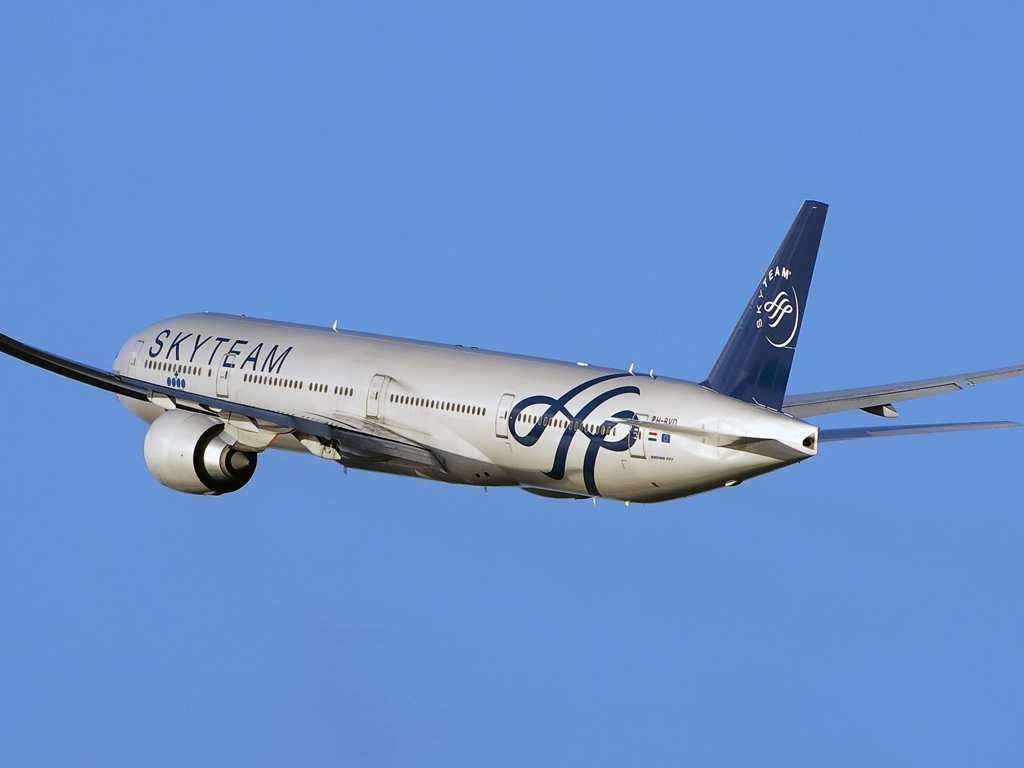Why is the image considered to have good quality? The image is considered to have good quality because details such as the aircraft's livery, registration number, and even the finer aspects of its design are well-preserved. The colors are vibrant and there is a crisp contrast between the aircraft and the clear blue sky, emphasizing the subject without any sign of overexposure or blur. 